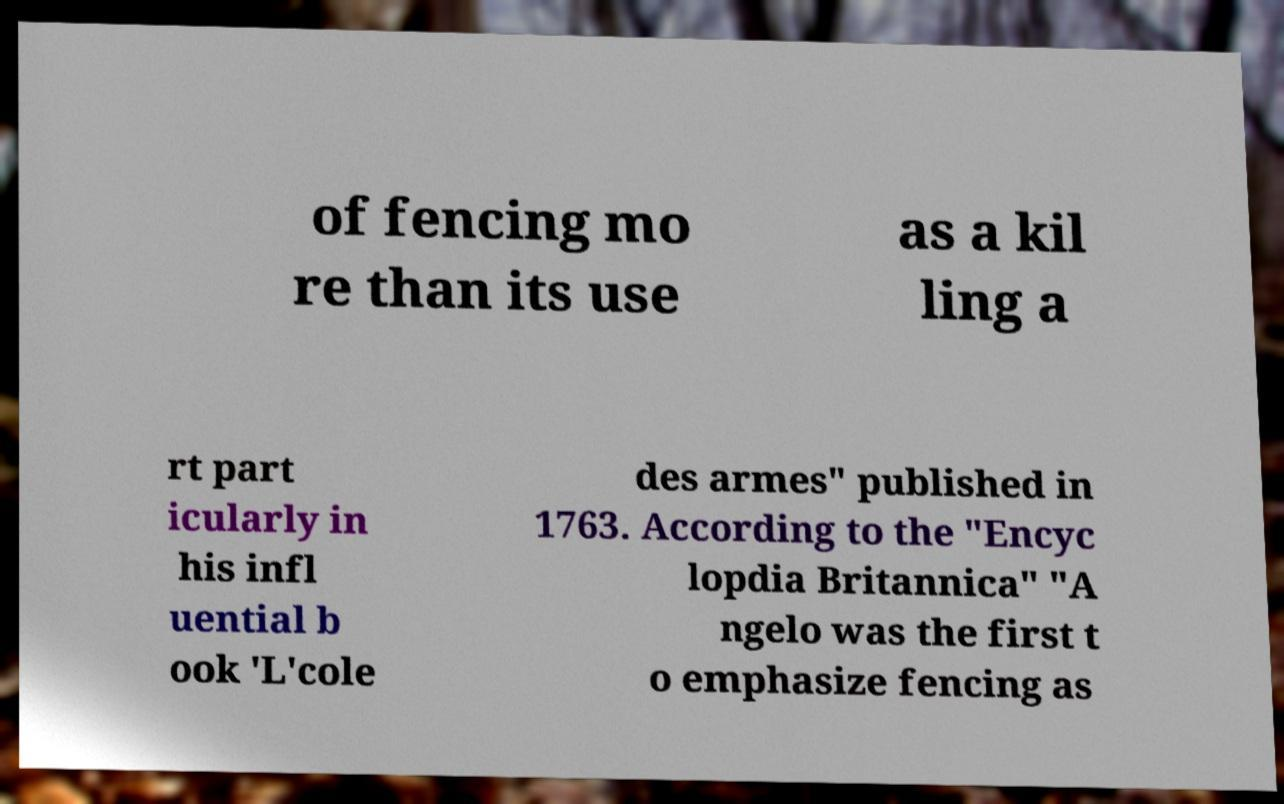What messages or text are displayed in this image? I need them in a readable, typed format. of fencing mo re than its use as a kil ling a rt part icularly in his infl uential b ook 'L'cole des armes" published in 1763. According to the "Encyc lopdia Britannica" "A ngelo was the first t o emphasize fencing as 